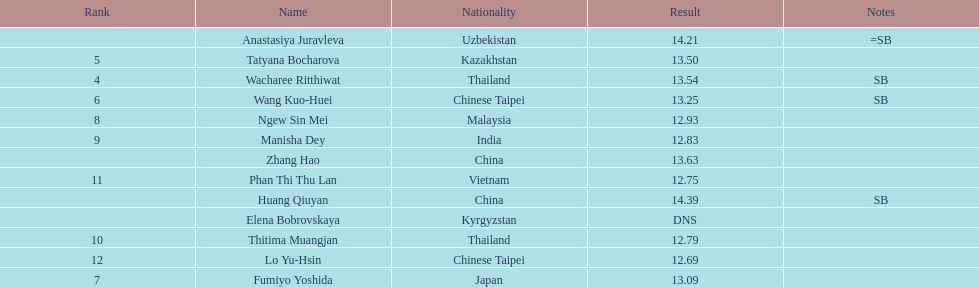Could you parse the entire table? {'header': ['Rank', 'Name', 'Nationality', 'Result', 'Notes'], 'rows': [['', 'Anastasiya Juravleva', 'Uzbekistan', '14.21', '=SB'], ['5', 'Tatyana Bocharova', 'Kazakhstan', '13.50', ''], ['4', 'Wacharee Ritthiwat', 'Thailand', '13.54', 'SB'], ['6', 'Wang Kuo-Huei', 'Chinese Taipei', '13.25', 'SB'], ['8', 'Ngew Sin Mei', 'Malaysia', '12.93', ''], ['9', 'Manisha Dey', 'India', '12.83', ''], ['', 'Zhang Hao', 'China', '13.63', ''], ['11', 'Phan Thi Thu Lan', 'Vietnam', '12.75', ''], ['', 'Huang Qiuyan', 'China', '14.39', 'SB'], ['', 'Elena Bobrovskaya', 'Kyrgyzstan', 'DNS', ''], ['10', 'Thitima Muangjan', 'Thailand', '12.79', ''], ['12', 'Lo Yu-Hsin', 'Chinese Taipei', '12.69', ''], ['7', 'Fumiyo Yoshida', 'Japan', '13.09', '']]} How many contestants were from thailand? 2. 